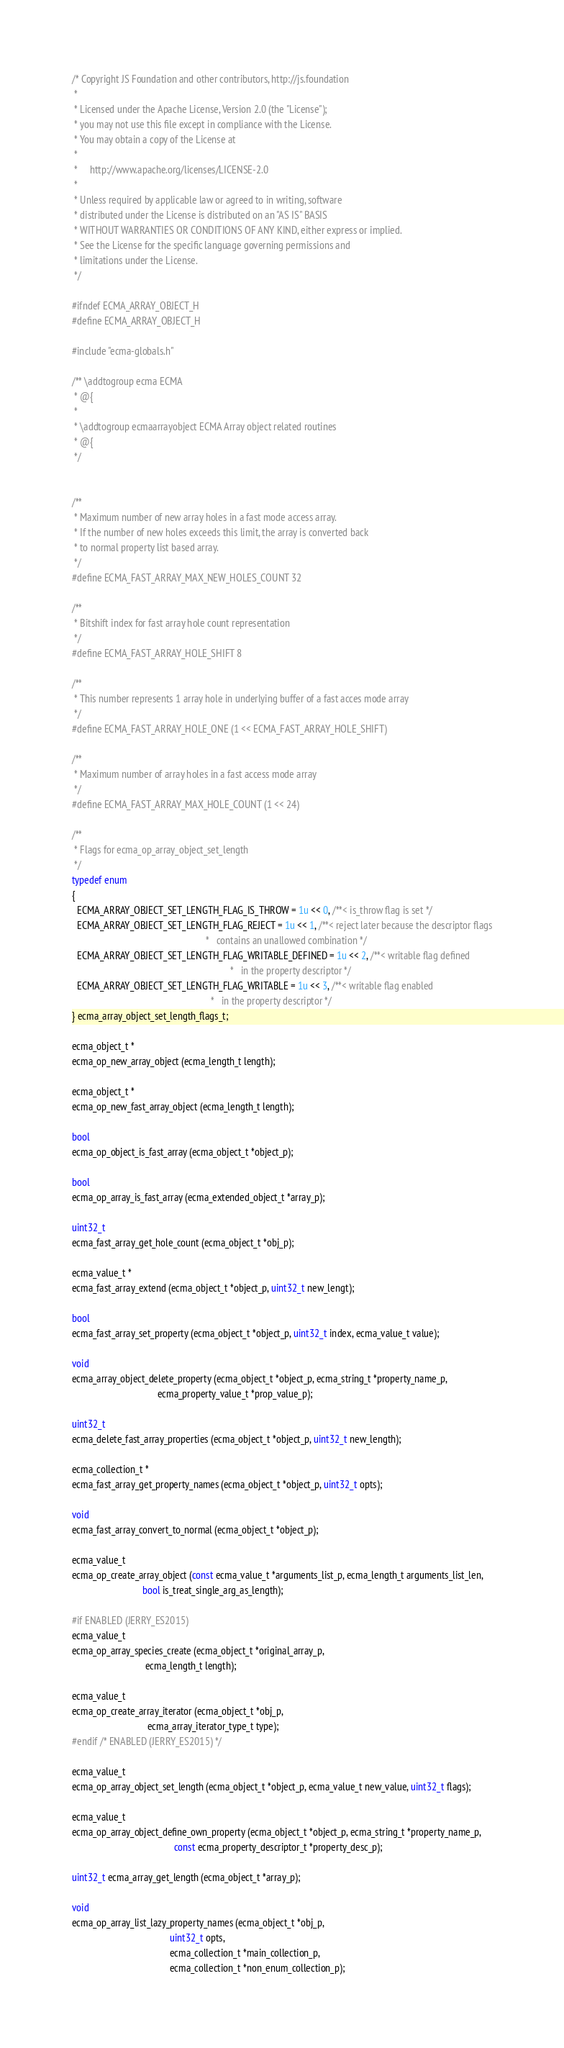Convert code to text. <code><loc_0><loc_0><loc_500><loc_500><_C_>/* Copyright JS Foundation and other contributors, http://js.foundation
 *
 * Licensed under the Apache License, Version 2.0 (the "License");
 * you may not use this file except in compliance with the License.
 * You may obtain a copy of the License at
 *
 *     http://www.apache.org/licenses/LICENSE-2.0
 *
 * Unless required by applicable law or agreed to in writing, software
 * distributed under the License is distributed on an "AS IS" BASIS
 * WITHOUT WARRANTIES OR CONDITIONS OF ANY KIND, either express or implied.
 * See the License for the specific language governing permissions and
 * limitations under the License.
 */

#ifndef ECMA_ARRAY_OBJECT_H
#define ECMA_ARRAY_OBJECT_H

#include "ecma-globals.h"

/** \addtogroup ecma ECMA
 * @{
 *
 * \addtogroup ecmaarrayobject ECMA Array object related routines
 * @{
 */


/**
 * Maximum number of new array holes in a fast mode access array.
 * If the number of new holes exceeds this limit, the array is converted back
 * to normal property list based array.
 */
#define ECMA_FAST_ARRAY_MAX_NEW_HOLES_COUNT 32

/**
 * Bitshift index for fast array hole count representation
 */
#define ECMA_FAST_ARRAY_HOLE_SHIFT 8

/**
 * This number represents 1 array hole in underlying buffer of a fast acces mode array
 */
#define ECMA_FAST_ARRAY_HOLE_ONE (1 << ECMA_FAST_ARRAY_HOLE_SHIFT)

/**
 * Maximum number of array holes in a fast access mode array
 */
#define ECMA_FAST_ARRAY_MAX_HOLE_COUNT (1 << 24)

/**
 * Flags for ecma_op_array_object_set_length
 */
typedef enum
{
  ECMA_ARRAY_OBJECT_SET_LENGTH_FLAG_IS_THROW = 1u << 0, /**< is_throw flag is set */
  ECMA_ARRAY_OBJECT_SET_LENGTH_FLAG_REJECT = 1u << 1, /**< reject later because the descriptor flags
                                                       *   contains an unallowed combination */
  ECMA_ARRAY_OBJECT_SET_LENGTH_FLAG_WRITABLE_DEFINED = 1u << 2, /**< writable flag defined
                                                                 *   in the property descriptor */
  ECMA_ARRAY_OBJECT_SET_LENGTH_FLAG_WRITABLE = 1u << 3, /**< writable flag enabled
                                                         *   in the property descriptor */
} ecma_array_object_set_length_flags_t;

ecma_object_t *
ecma_op_new_array_object (ecma_length_t length);

ecma_object_t *
ecma_op_new_fast_array_object (ecma_length_t length);

bool
ecma_op_object_is_fast_array (ecma_object_t *object_p);

bool
ecma_op_array_is_fast_array (ecma_extended_object_t *array_p);

uint32_t
ecma_fast_array_get_hole_count (ecma_object_t *obj_p);

ecma_value_t *
ecma_fast_array_extend (ecma_object_t *object_p, uint32_t new_lengt);

bool
ecma_fast_array_set_property (ecma_object_t *object_p, uint32_t index, ecma_value_t value);

void
ecma_array_object_delete_property (ecma_object_t *object_p, ecma_string_t *property_name_p,
                                   ecma_property_value_t *prop_value_p);

uint32_t
ecma_delete_fast_array_properties (ecma_object_t *object_p, uint32_t new_length);

ecma_collection_t *
ecma_fast_array_get_property_names (ecma_object_t *object_p, uint32_t opts);

void
ecma_fast_array_convert_to_normal (ecma_object_t *object_p);

ecma_value_t
ecma_op_create_array_object (const ecma_value_t *arguments_list_p, ecma_length_t arguments_list_len,
                             bool is_treat_single_arg_as_length);

#if ENABLED (JERRY_ES2015)
ecma_value_t
ecma_op_array_species_create (ecma_object_t *original_array_p,
                              ecma_length_t length);

ecma_value_t
ecma_op_create_array_iterator (ecma_object_t *obj_p,
                               ecma_array_iterator_type_t type);
#endif /* ENABLED (JERRY_ES2015) */

ecma_value_t
ecma_op_array_object_set_length (ecma_object_t *object_p, ecma_value_t new_value, uint32_t flags);

ecma_value_t
ecma_op_array_object_define_own_property (ecma_object_t *object_p, ecma_string_t *property_name_p,
                                          const ecma_property_descriptor_t *property_desc_p);

uint32_t ecma_array_get_length (ecma_object_t *array_p);

void
ecma_op_array_list_lazy_property_names (ecma_object_t *obj_p,
                                        uint32_t opts,
                                        ecma_collection_t *main_collection_p,
                                        ecma_collection_t *non_enum_collection_p);
</code> 